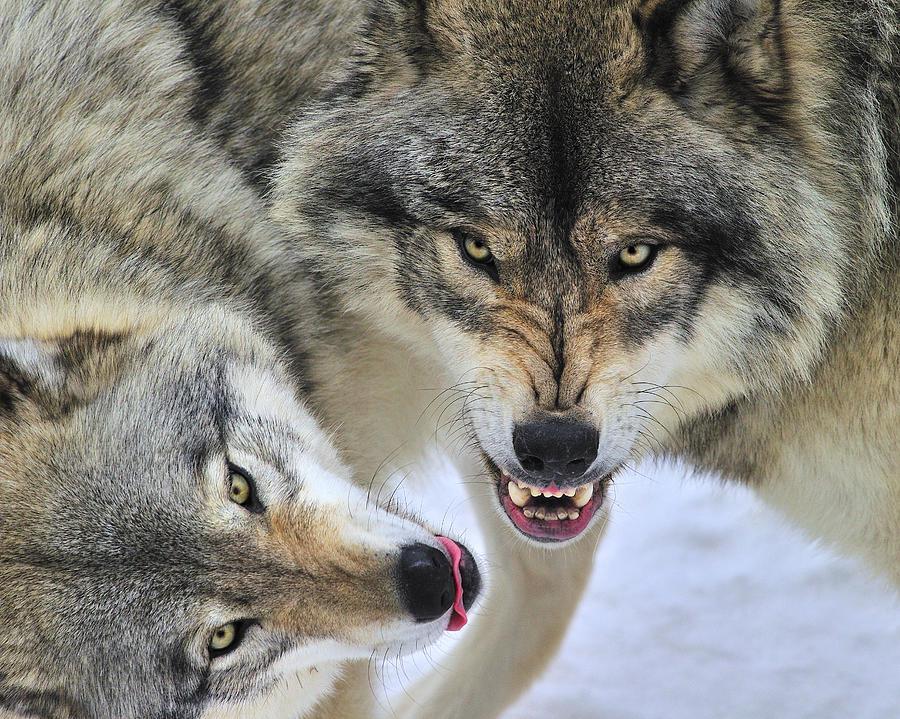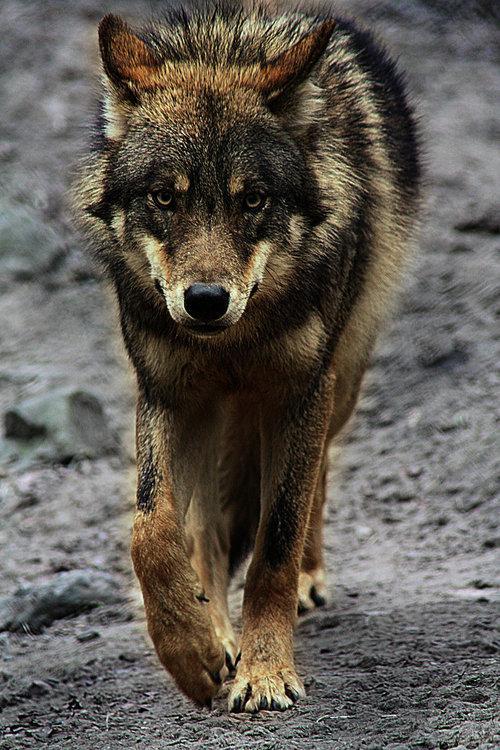The first image is the image on the left, the second image is the image on the right. Considering the images on both sides, is "One wolf is facing to the right." valid? Answer yes or no. Yes. The first image is the image on the left, the second image is the image on the right. Analyze the images presented: Is the assertion "Each image shows the face of one wolf, and one of the wolves depicted looks straight ahead, while the other is turned slightly to the left." valid? Answer yes or no. No. 